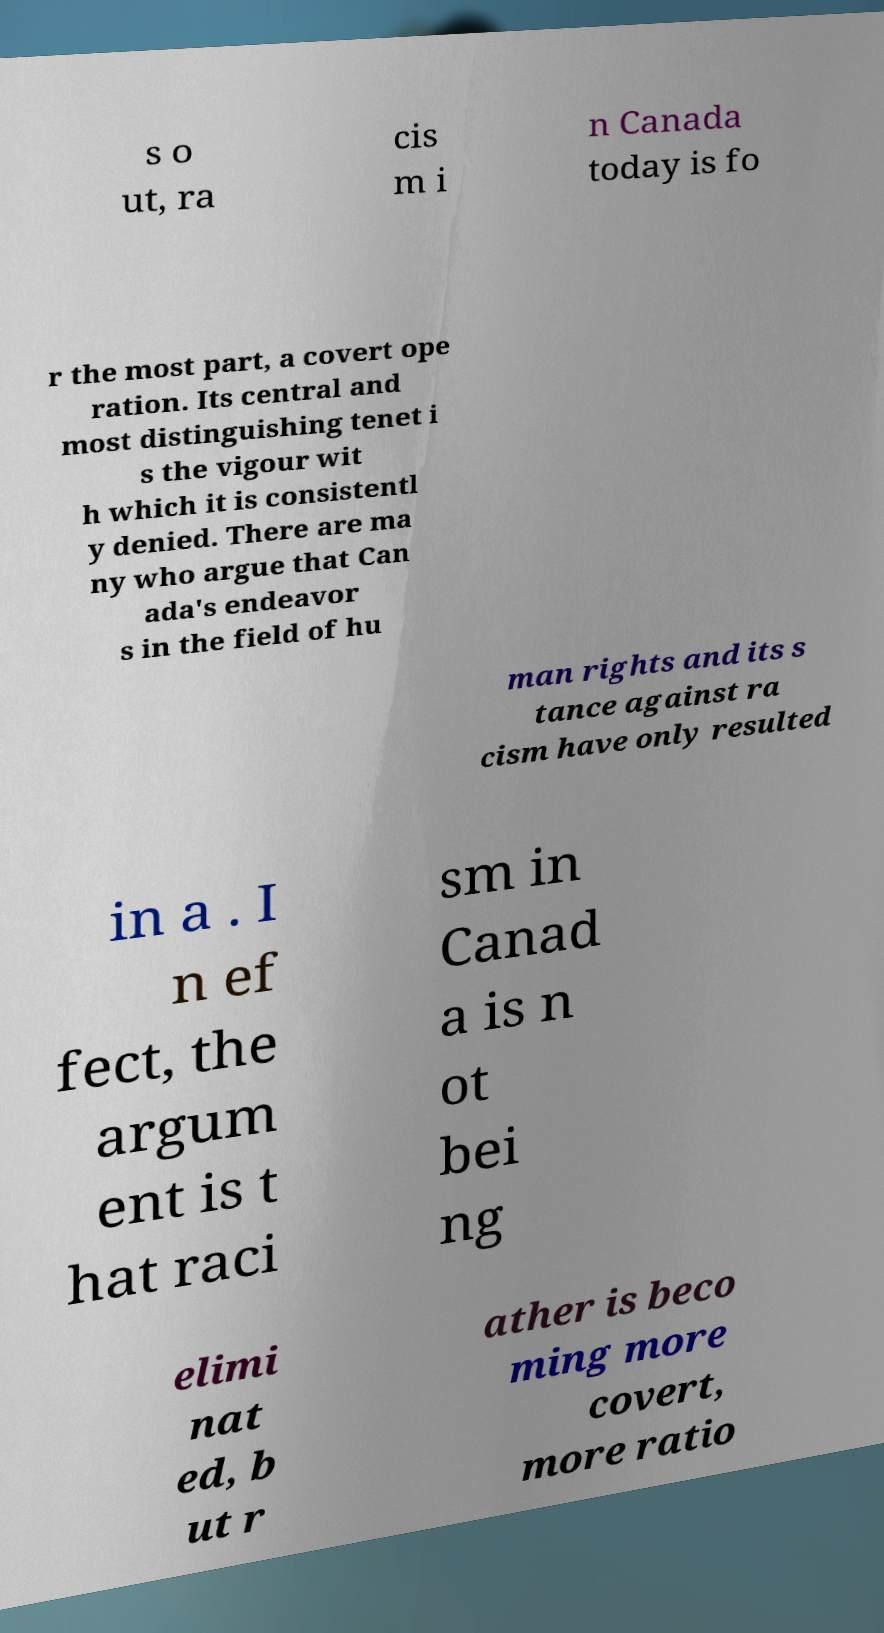Could you extract and type out the text from this image? s o ut, ra cis m i n Canada today is fo r the most part, a covert ope ration. Its central and most distinguishing tenet i s the vigour wit h which it is consistentl y denied. There are ma ny who argue that Can ada's endeavor s in the field of hu man rights and its s tance against ra cism have only resulted in a . I n ef fect, the argum ent is t hat raci sm in Canad a is n ot bei ng elimi nat ed, b ut r ather is beco ming more covert, more ratio 